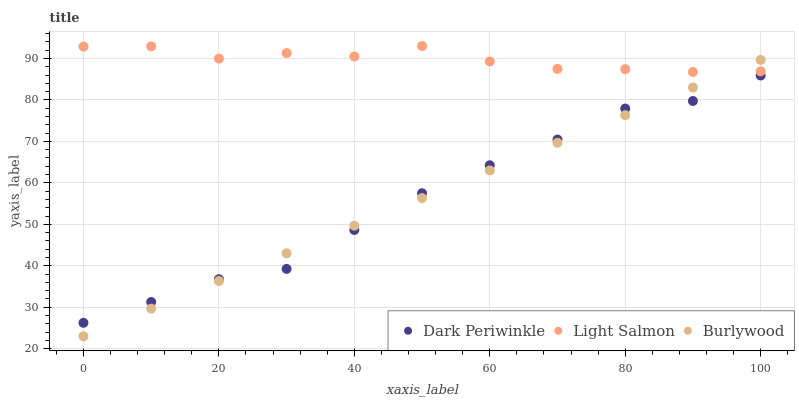Does Dark Periwinkle have the minimum area under the curve?
Answer yes or no. Yes. Does Light Salmon have the maximum area under the curve?
Answer yes or no. Yes. Does Light Salmon have the minimum area under the curve?
Answer yes or no. No. Does Dark Periwinkle have the maximum area under the curve?
Answer yes or no. No. Is Burlywood the smoothest?
Answer yes or no. Yes. Is Dark Periwinkle the roughest?
Answer yes or no. Yes. Is Light Salmon the smoothest?
Answer yes or no. No. Is Light Salmon the roughest?
Answer yes or no. No. Does Burlywood have the lowest value?
Answer yes or no. Yes. Does Dark Periwinkle have the lowest value?
Answer yes or no. No. Does Light Salmon have the highest value?
Answer yes or no. Yes. Does Dark Periwinkle have the highest value?
Answer yes or no. No. Is Dark Periwinkle less than Light Salmon?
Answer yes or no. Yes. Is Light Salmon greater than Dark Periwinkle?
Answer yes or no. Yes. Does Dark Periwinkle intersect Burlywood?
Answer yes or no. Yes. Is Dark Periwinkle less than Burlywood?
Answer yes or no. No. Is Dark Periwinkle greater than Burlywood?
Answer yes or no. No. Does Dark Periwinkle intersect Light Salmon?
Answer yes or no. No. 